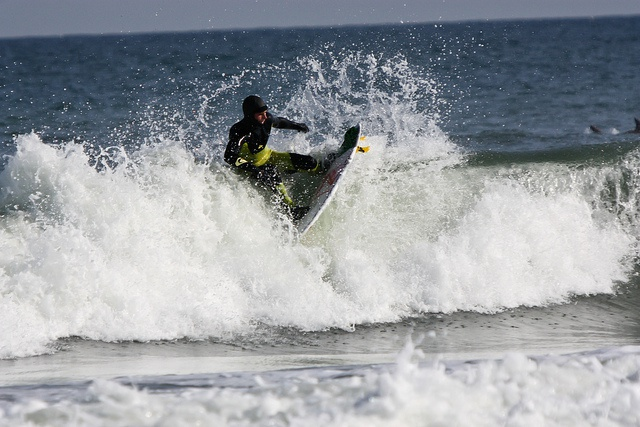Describe the objects in this image and their specific colors. I can see people in gray, black, darkgray, and darkgreen tones, surfboard in gray, black, lightgray, and darkgray tones, and people in gray, black, and darkblue tones in this image. 